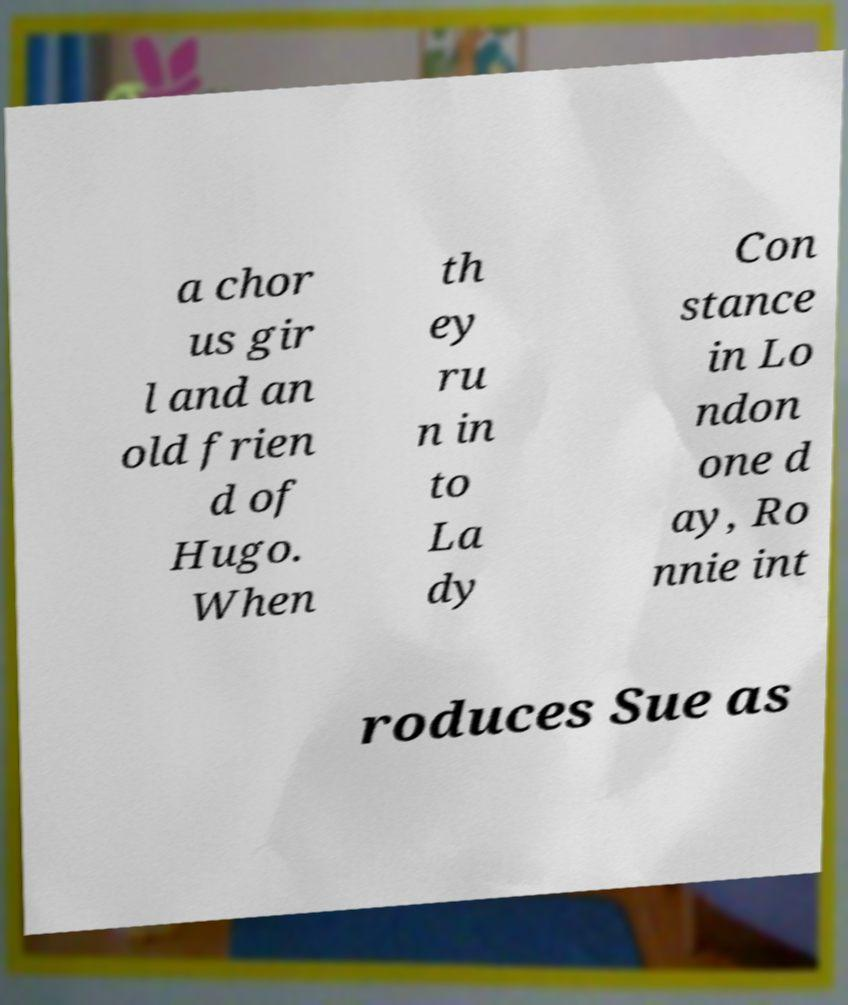Please identify and transcribe the text found in this image. a chor us gir l and an old frien d of Hugo. When th ey ru n in to La dy Con stance in Lo ndon one d ay, Ro nnie int roduces Sue as 